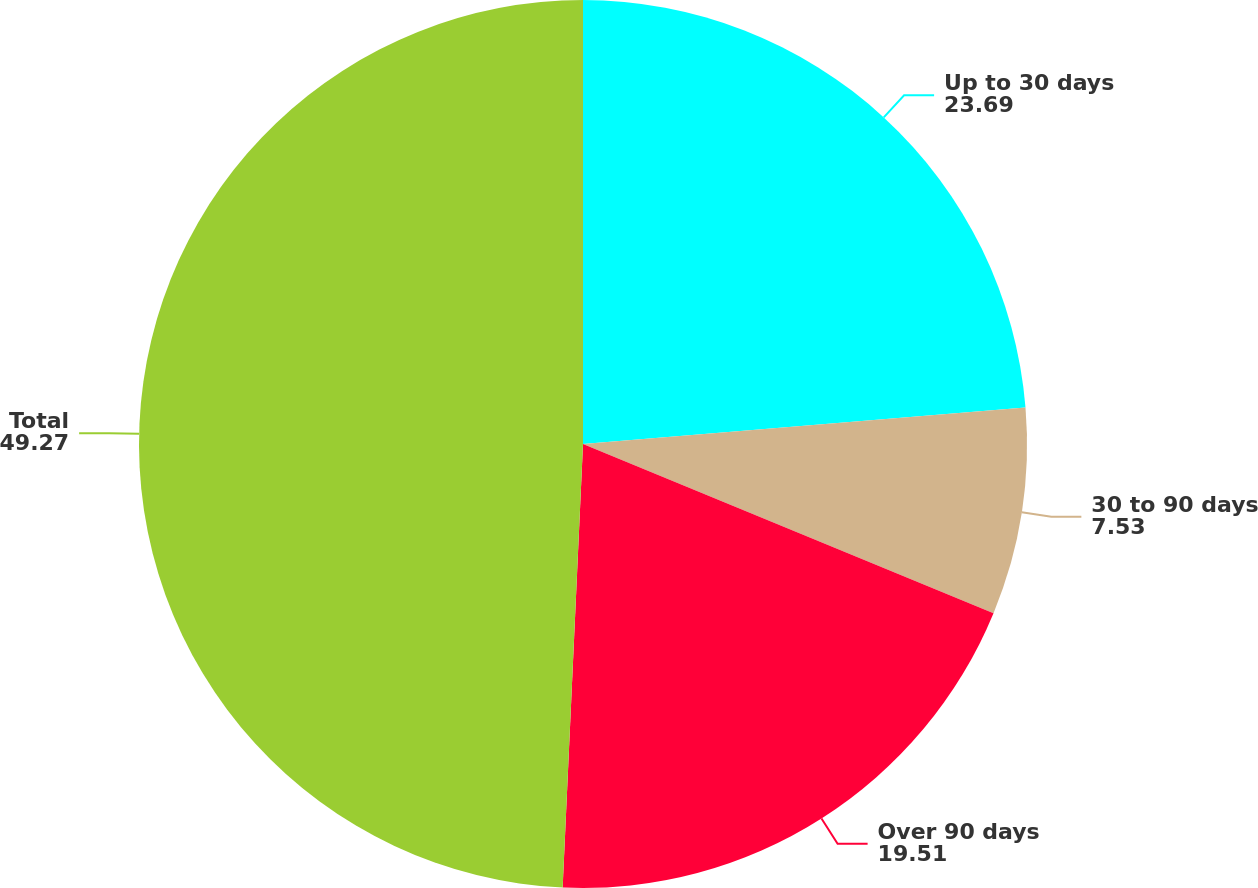<chart> <loc_0><loc_0><loc_500><loc_500><pie_chart><fcel>Up to 30 days<fcel>30 to 90 days<fcel>Over 90 days<fcel>Total<nl><fcel>23.69%<fcel>7.53%<fcel>19.51%<fcel>49.27%<nl></chart> 